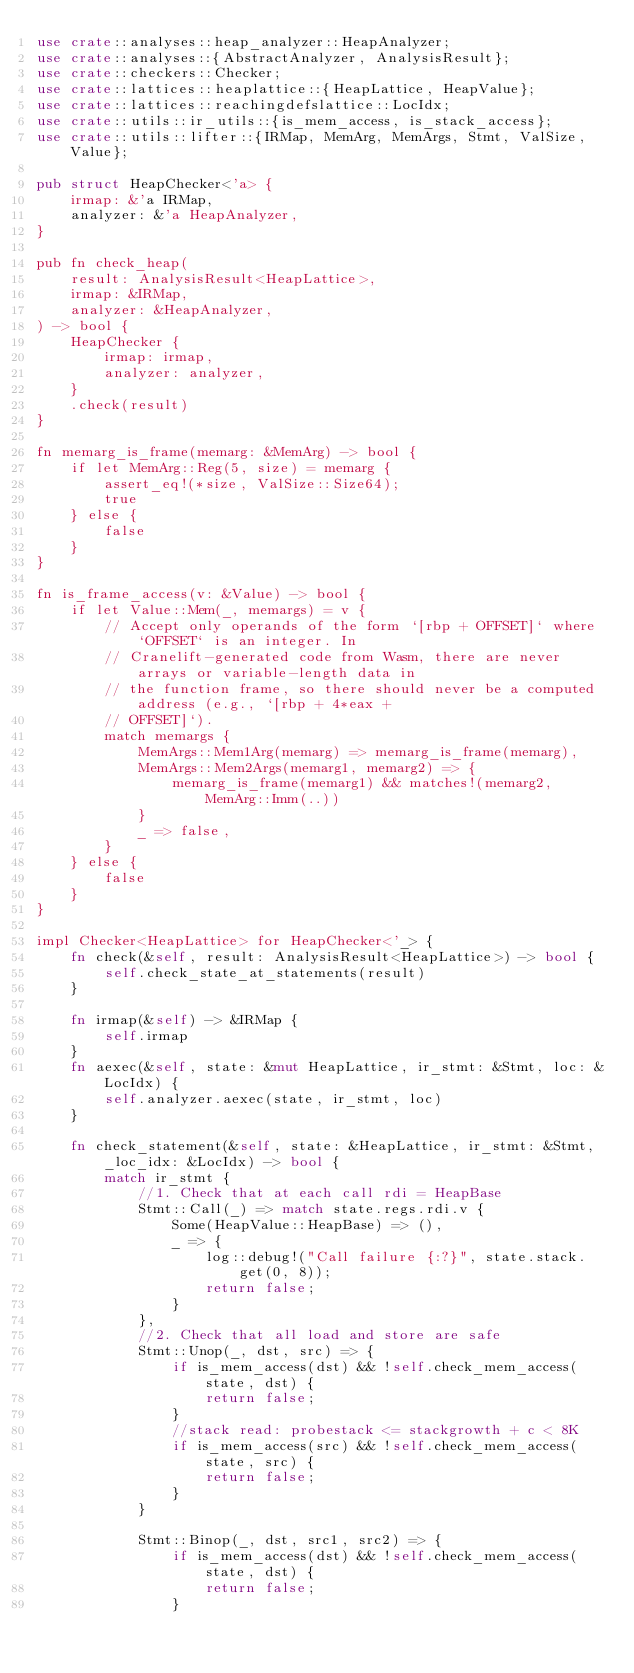Convert code to text. <code><loc_0><loc_0><loc_500><loc_500><_Rust_>use crate::analyses::heap_analyzer::HeapAnalyzer;
use crate::analyses::{AbstractAnalyzer, AnalysisResult};
use crate::checkers::Checker;
use crate::lattices::heaplattice::{HeapLattice, HeapValue};
use crate::lattices::reachingdefslattice::LocIdx;
use crate::utils::ir_utils::{is_mem_access, is_stack_access};
use crate::utils::lifter::{IRMap, MemArg, MemArgs, Stmt, ValSize, Value};

pub struct HeapChecker<'a> {
    irmap: &'a IRMap,
    analyzer: &'a HeapAnalyzer,
}

pub fn check_heap(
    result: AnalysisResult<HeapLattice>,
    irmap: &IRMap,
    analyzer: &HeapAnalyzer,
) -> bool {
    HeapChecker {
        irmap: irmap,
        analyzer: analyzer,
    }
    .check(result)
}

fn memarg_is_frame(memarg: &MemArg) -> bool {
    if let MemArg::Reg(5, size) = memarg {
        assert_eq!(*size, ValSize::Size64);
        true
    } else {
        false
    }
}

fn is_frame_access(v: &Value) -> bool {
    if let Value::Mem(_, memargs) = v {
        // Accept only operands of the form `[rbp + OFFSET]` where `OFFSET` is an integer. In
        // Cranelift-generated code from Wasm, there are never arrays or variable-length data in
        // the function frame, so there should never be a computed address (e.g., `[rbp + 4*eax +
        // OFFSET]`).
        match memargs {
            MemArgs::Mem1Arg(memarg) => memarg_is_frame(memarg),
            MemArgs::Mem2Args(memarg1, memarg2) => {
                memarg_is_frame(memarg1) && matches!(memarg2, MemArg::Imm(..))
            }
            _ => false,
        }
    } else {
        false
    }
}

impl Checker<HeapLattice> for HeapChecker<'_> {
    fn check(&self, result: AnalysisResult<HeapLattice>) -> bool {
        self.check_state_at_statements(result)
    }

    fn irmap(&self) -> &IRMap {
        self.irmap
    }
    fn aexec(&self, state: &mut HeapLattice, ir_stmt: &Stmt, loc: &LocIdx) {
        self.analyzer.aexec(state, ir_stmt, loc)
    }

    fn check_statement(&self, state: &HeapLattice, ir_stmt: &Stmt, _loc_idx: &LocIdx) -> bool {
        match ir_stmt {
            //1. Check that at each call rdi = HeapBase
            Stmt::Call(_) => match state.regs.rdi.v {
                Some(HeapValue::HeapBase) => (),
                _ => {
                    log::debug!("Call failure {:?}", state.stack.get(0, 8));
                    return false;
                }
            },
            //2. Check that all load and store are safe
            Stmt::Unop(_, dst, src) => {
                if is_mem_access(dst) && !self.check_mem_access(state, dst) {
                    return false;
                }
                //stack read: probestack <= stackgrowth + c < 8K
                if is_mem_access(src) && !self.check_mem_access(state, src) {
                    return false;
                }
            }

            Stmt::Binop(_, dst, src1, src2) => {
                if is_mem_access(dst) && !self.check_mem_access(state, dst) {
                    return false;
                }</code> 